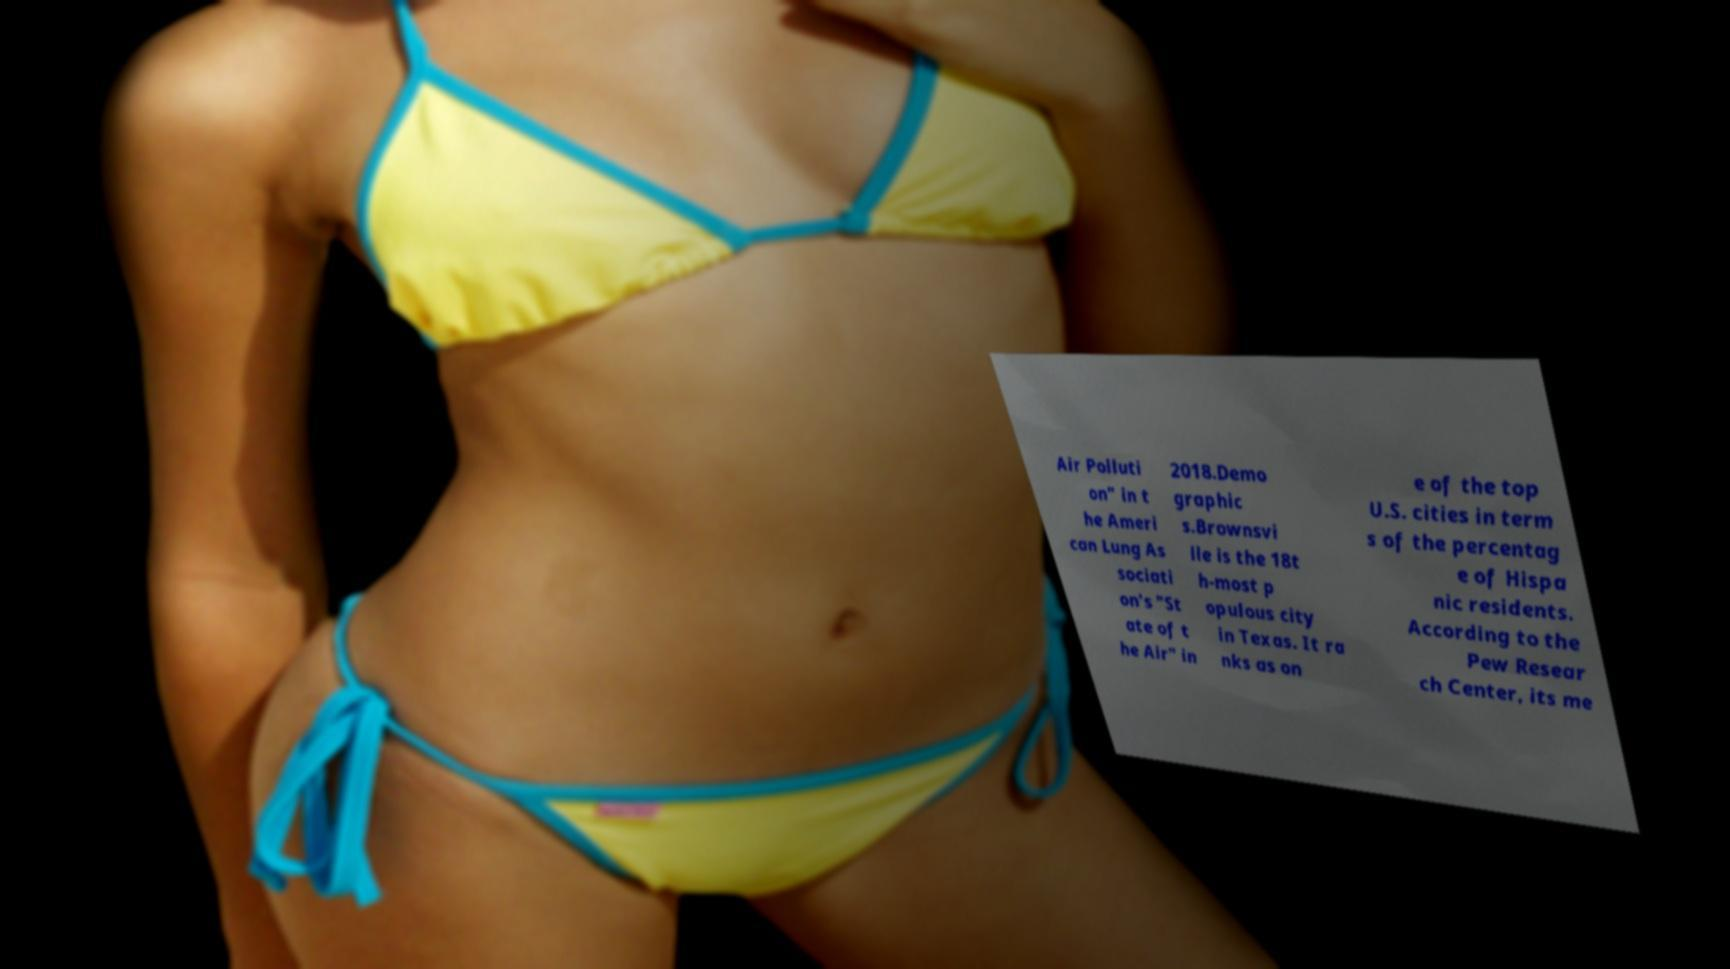I need the written content from this picture converted into text. Can you do that? Air Polluti on" in t he Ameri can Lung As sociati on's "St ate of t he Air" in 2018.Demo graphic s.Brownsvi lle is the 18t h-most p opulous city in Texas. It ra nks as on e of the top U.S. cities in term s of the percentag e of Hispa nic residents. According to the Pew Resear ch Center, its me 